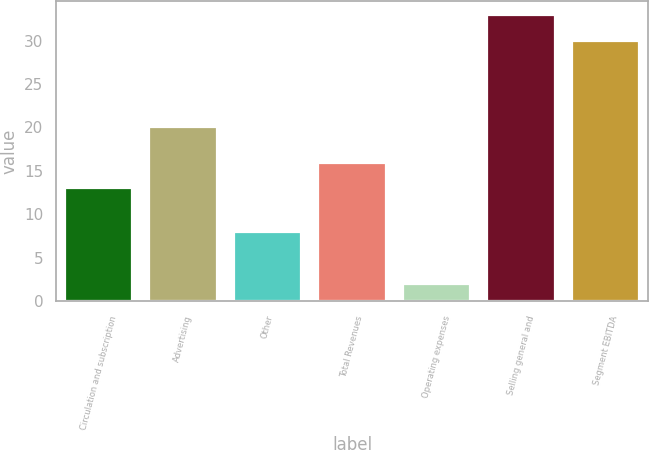Convert chart to OTSL. <chart><loc_0><loc_0><loc_500><loc_500><bar_chart><fcel>Circulation and subscription<fcel>Advertising<fcel>Other<fcel>Total Revenues<fcel>Operating expenses<fcel>Selling general and<fcel>Segment EBITDA<nl><fcel>13<fcel>20<fcel>8<fcel>15.9<fcel>2<fcel>32.9<fcel>30<nl></chart> 